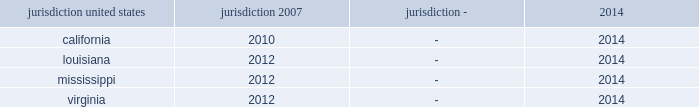Interest and penalties with respect to unrecognized tax benefits were $ 3 million as of each of december 31 , 2015 and 2014 .
During 2013 , the company recorded a reduction of $ 14 million to its liability for uncertain tax positions related to a change approved by the irs for the allocation of interest costs to long term construction contracts at ingalls .
This change was made on a prospective basis only and did not impact the tax returns filed for years prior to 2013 .
The table summarizes the tax years that are either currently under examination or remain open under the applicable statute of limitations and subject to examination by the major tax jurisdictions in which the company operates: .
Although the company believes it has adequately provided for all uncertain tax positions , amounts asserted by taxing authorities could be greater than the company's accrued position .
Accordingly , additional provisions for federal and state income tax related matters could be recorded in the future as revised estimates are made or the underlying matters are effectively settled or otherwise resolved .
Conversely , the company could settle positions with the tax authorities for amounts lower than have been accrued .
The company believes that it is reasonably possible that during the next 12 months the company's liability for uncertain tax positions may decrease by approximately $ 2 million due to statute of limitation expirations .
The company recognizes accrued interest and penalties related to uncertain tax positions in income tax expense .
The irs is currently conducting an examination of northrop grumman's consolidated tax returns , of which hii was part , for the years 2007 through the spin-off .
During 2013 the company entered into the pre-compliance assurance process with the irs for years 2011 and 2012 .
The company is part of the irs compliance assurance process program for the 2014 , 2015 , and 2016 tax years .
Open tax years related to state jurisdictions remain subject to examination .
As of march 31 , 2011 , the date of the spin-off , the company's liability for uncertain tax positions was approximately $ 4 million , net of federal benefit , which related solely to state income tax positions .
Under the terms of the separation agreement , northrop grumman is obligated to reimburse hii for any settlement liabilities paid by hii to any government authority for tax periods prior to the spin-off , which include state income taxes .
As a result , the company recorded in other assets a reimbursement receivable of approximately $ 4 million , net of federal benefit , related to uncertain tax positions for state income taxes as of the date of the spin-off .
In 2014 , the statute of limitations expired for the $ 4 million liability related to state uncertain tax positions as of the spin-off date .
Accordingly , the $ 4 million liability and the associated reimbursement receivable were written off .
On september 13 , 2013 , the treasury department and the internal revenue service issued final regulations regarding the deduction and capitalization of amounts paid to acquire , produce , improve , or dispose of tangible personal property .
These regulations are generally effective for tax years beginning on or after january 1 , 2014 .
The application of these regulations did not have a material impact on the company's consolidated financial statements .
Deferred income taxes - deferred income taxes reflect the net tax effects of temporary differences between the carrying amounts of assets and liabilities for financial reporting purposes and for income tax purposes .
Such amounts are classified in the consolidated statements of financial position as current or non-current assets or liabilities based upon the classification of the related assets and liabilities. .
What is the current tax examination period in virginia , in years? 
Computations: (2014 - 2012)
Answer: 2.0. 